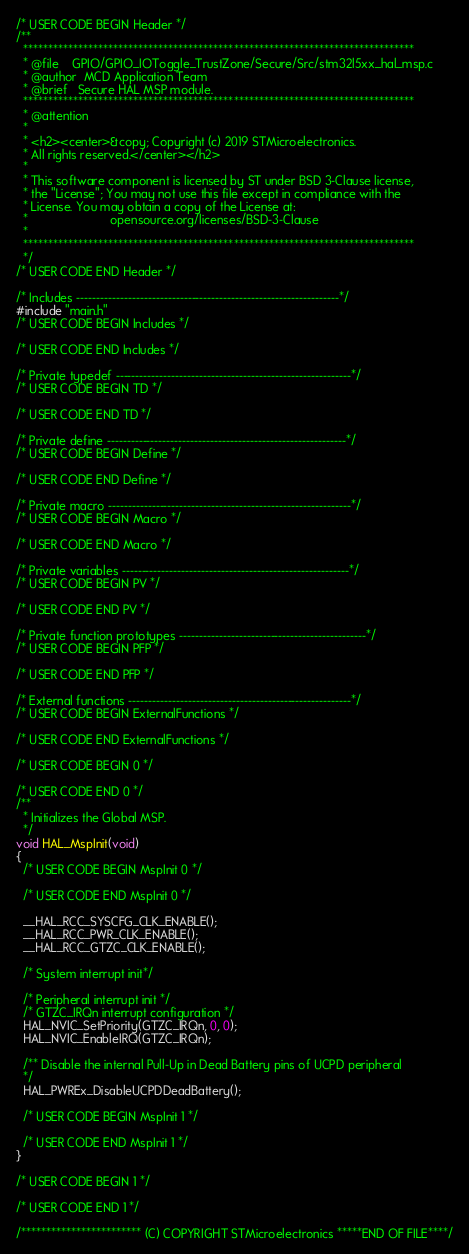<code> <loc_0><loc_0><loc_500><loc_500><_C_>/* USER CODE BEGIN Header */
/**
  ******************************************************************************
  * @file    GPIO/GPIO_IOToggle_TrustZone/Secure/Src/stm32l5xx_hal_msp.c
  * @author  MCD Application Team
  * @brief   Secure HAL MSP module.
  ******************************************************************************
  * @attention
  *
  * <h2><center>&copy; Copyright (c) 2019 STMicroelectronics.
  * All rights reserved.</center></h2>
  *
  * This software component is licensed by ST under BSD 3-Clause license,
  * the "License"; You may not use this file except in compliance with the
  * License. You may obtain a copy of the License at:
  *                        opensource.org/licenses/BSD-3-Clause
  *
  ******************************************************************************
  */
/* USER CODE END Header */

/* Includes ------------------------------------------------------------------*/
#include "main.h"
/* USER CODE BEGIN Includes */

/* USER CODE END Includes */

/* Private typedef -----------------------------------------------------------*/
/* USER CODE BEGIN TD */

/* USER CODE END TD */

/* Private define ------------------------------------------------------------*/
/* USER CODE BEGIN Define */

/* USER CODE END Define */

/* Private macro -------------------------------------------------------------*/
/* USER CODE BEGIN Macro */

/* USER CODE END Macro */

/* Private variables ---------------------------------------------------------*/
/* USER CODE BEGIN PV */

/* USER CODE END PV */

/* Private function prototypes -----------------------------------------------*/
/* USER CODE BEGIN PFP */

/* USER CODE END PFP */

/* External functions --------------------------------------------------------*/
/* USER CODE BEGIN ExternalFunctions */

/* USER CODE END ExternalFunctions */

/* USER CODE BEGIN 0 */

/* USER CODE END 0 */
/**
  * Initializes the Global MSP.
  */
void HAL_MspInit(void)
{
  /* USER CODE BEGIN MspInit 0 */

  /* USER CODE END MspInit 0 */

  __HAL_RCC_SYSCFG_CLK_ENABLE();
  __HAL_RCC_PWR_CLK_ENABLE();
  __HAL_RCC_GTZC_CLK_ENABLE();

  /* System interrupt init*/

  /* Peripheral interrupt init */
  /* GTZC_IRQn interrupt configuration */
  HAL_NVIC_SetPriority(GTZC_IRQn, 0, 0);
  HAL_NVIC_EnableIRQ(GTZC_IRQn);

  /** Disable the internal Pull-Up in Dead Battery pins of UCPD peripheral
  */
  HAL_PWREx_DisableUCPDDeadBattery();

  /* USER CODE BEGIN MspInit 1 */

  /* USER CODE END MspInit 1 */
}

/* USER CODE BEGIN 1 */

/* USER CODE END 1 */

/************************ (C) COPYRIGHT STMicroelectronics *****END OF FILE****/
</code> 